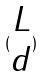<formula> <loc_0><loc_0><loc_500><loc_500>( \begin{matrix} L \\ d \end{matrix} )</formula> 